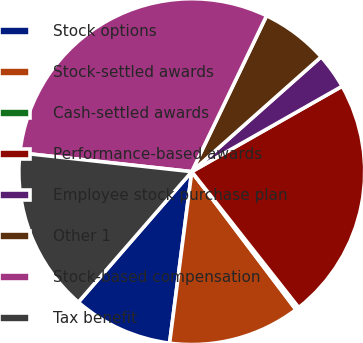Convert chart. <chart><loc_0><loc_0><loc_500><loc_500><pie_chart><fcel>Stock options<fcel>Stock-settled awards<fcel>Cash-settled awards<fcel>Performance-based awards<fcel>Employee stock purchase plan<fcel>Other 1<fcel>Stock-based compensation<fcel>Tax benefit<nl><fcel>9.34%<fcel>12.34%<fcel>0.32%<fcel>22.61%<fcel>3.33%<fcel>6.33%<fcel>30.38%<fcel>15.35%<nl></chart> 